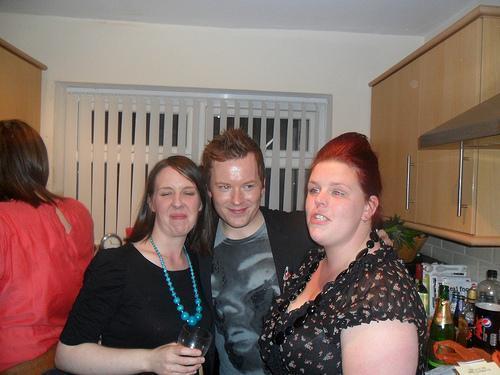How many men are pictured?
Give a very brief answer. 1. How many people are pictured?
Give a very brief answer. 4. How many people are wearing necklace?
Give a very brief answer. 1. 